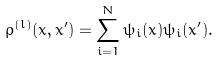Convert formula to latex. <formula><loc_0><loc_0><loc_500><loc_500>\rho ^ { ( l ) } ( x , x ^ { \prime } ) = \sum _ { i = 1 } ^ { N } \psi _ { i } ( x ) \psi _ { i } ( x ^ { \prime } ) .</formula> 